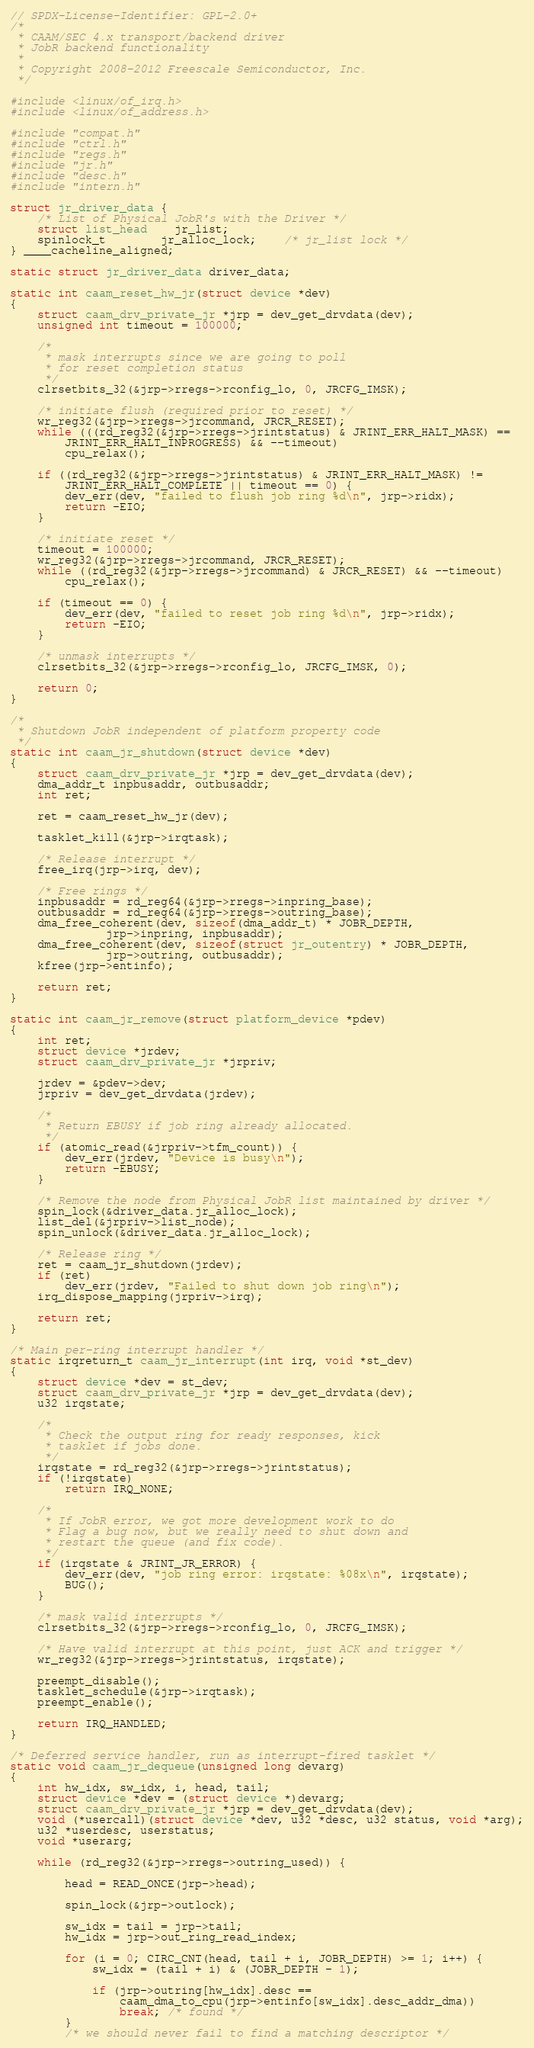<code> <loc_0><loc_0><loc_500><loc_500><_C_>// SPDX-License-Identifier: GPL-2.0+
/*
 * CAAM/SEC 4.x transport/backend driver
 * JobR backend functionality
 *
 * Copyright 2008-2012 Freescale Semiconductor, Inc.
 */

#include <linux/of_irq.h>
#include <linux/of_address.h>

#include "compat.h"
#include "ctrl.h"
#include "regs.h"
#include "jr.h"
#include "desc.h"
#include "intern.h"

struct jr_driver_data {
	/* List of Physical JobR's with the Driver */
	struct list_head	jr_list;
	spinlock_t		jr_alloc_lock;	/* jr_list lock */
} ____cacheline_aligned;

static struct jr_driver_data driver_data;

static int caam_reset_hw_jr(struct device *dev)
{
	struct caam_drv_private_jr *jrp = dev_get_drvdata(dev);
	unsigned int timeout = 100000;

	/*
	 * mask interrupts since we are going to poll
	 * for reset completion status
	 */
	clrsetbits_32(&jrp->rregs->rconfig_lo, 0, JRCFG_IMSK);

	/* initiate flush (required prior to reset) */
	wr_reg32(&jrp->rregs->jrcommand, JRCR_RESET);
	while (((rd_reg32(&jrp->rregs->jrintstatus) & JRINT_ERR_HALT_MASK) ==
		JRINT_ERR_HALT_INPROGRESS) && --timeout)
		cpu_relax();

	if ((rd_reg32(&jrp->rregs->jrintstatus) & JRINT_ERR_HALT_MASK) !=
	    JRINT_ERR_HALT_COMPLETE || timeout == 0) {
		dev_err(dev, "failed to flush job ring %d\n", jrp->ridx);
		return -EIO;
	}

	/* initiate reset */
	timeout = 100000;
	wr_reg32(&jrp->rregs->jrcommand, JRCR_RESET);
	while ((rd_reg32(&jrp->rregs->jrcommand) & JRCR_RESET) && --timeout)
		cpu_relax();

	if (timeout == 0) {
		dev_err(dev, "failed to reset job ring %d\n", jrp->ridx);
		return -EIO;
	}

	/* unmask interrupts */
	clrsetbits_32(&jrp->rregs->rconfig_lo, JRCFG_IMSK, 0);

	return 0;
}

/*
 * Shutdown JobR independent of platform property code
 */
static int caam_jr_shutdown(struct device *dev)
{
	struct caam_drv_private_jr *jrp = dev_get_drvdata(dev);
	dma_addr_t inpbusaddr, outbusaddr;
	int ret;

	ret = caam_reset_hw_jr(dev);

	tasklet_kill(&jrp->irqtask);

	/* Release interrupt */
	free_irq(jrp->irq, dev);

	/* Free rings */
	inpbusaddr = rd_reg64(&jrp->rregs->inpring_base);
	outbusaddr = rd_reg64(&jrp->rregs->outring_base);
	dma_free_coherent(dev, sizeof(dma_addr_t) * JOBR_DEPTH,
			  jrp->inpring, inpbusaddr);
	dma_free_coherent(dev, sizeof(struct jr_outentry) * JOBR_DEPTH,
			  jrp->outring, outbusaddr);
	kfree(jrp->entinfo);

	return ret;
}

static int caam_jr_remove(struct platform_device *pdev)
{
	int ret;
	struct device *jrdev;
	struct caam_drv_private_jr *jrpriv;

	jrdev = &pdev->dev;
	jrpriv = dev_get_drvdata(jrdev);

	/*
	 * Return EBUSY if job ring already allocated.
	 */
	if (atomic_read(&jrpriv->tfm_count)) {
		dev_err(jrdev, "Device is busy\n");
		return -EBUSY;
	}

	/* Remove the node from Physical JobR list maintained by driver */
	spin_lock(&driver_data.jr_alloc_lock);
	list_del(&jrpriv->list_node);
	spin_unlock(&driver_data.jr_alloc_lock);

	/* Release ring */
	ret = caam_jr_shutdown(jrdev);
	if (ret)
		dev_err(jrdev, "Failed to shut down job ring\n");
	irq_dispose_mapping(jrpriv->irq);

	return ret;
}

/* Main per-ring interrupt handler */
static irqreturn_t caam_jr_interrupt(int irq, void *st_dev)
{
	struct device *dev = st_dev;
	struct caam_drv_private_jr *jrp = dev_get_drvdata(dev);
	u32 irqstate;

	/*
	 * Check the output ring for ready responses, kick
	 * tasklet if jobs done.
	 */
	irqstate = rd_reg32(&jrp->rregs->jrintstatus);
	if (!irqstate)
		return IRQ_NONE;

	/*
	 * If JobR error, we got more development work to do
	 * Flag a bug now, but we really need to shut down and
	 * restart the queue (and fix code).
	 */
	if (irqstate & JRINT_JR_ERROR) {
		dev_err(dev, "job ring error: irqstate: %08x\n", irqstate);
		BUG();
	}

	/* mask valid interrupts */
	clrsetbits_32(&jrp->rregs->rconfig_lo, 0, JRCFG_IMSK);

	/* Have valid interrupt at this point, just ACK and trigger */
	wr_reg32(&jrp->rregs->jrintstatus, irqstate);

	preempt_disable();
	tasklet_schedule(&jrp->irqtask);
	preempt_enable();

	return IRQ_HANDLED;
}

/* Deferred service handler, run as interrupt-fired tasklet */
static void caam_jr_dequeue(unsigned long devarg)
{
	int hw_idx, sw_idx, i, head, tail;
	struct device *dev = (struct device *)devarg;
	struct caam_drv_private_jr *jrp = dev_get_drvdata(dev);
	void (*usercall)(struct device *dev, u32 *desc, u32 status, void *arg);
	u32 *userdesc, userstatus;
	void *userarg;

	while (rd_reg32(&jrp->rregs->outring_used)) {

		head = READ_ONCE(jrp->head);

		spin_lock(&jrp->outlock);

		sw_idx = tail = jrp->tail;
		hw_idx = jrp->out_ring_read_index;

		for (i = 0; CIRC_CNT(head, tail + i, JOBR_DEPTH) >= 1; i++) {
			sw_idx = (tail + i) & (JOBR_DEPTH - 1);

			if (jrp->outring[hw_idx].desc ==
			    caam_dma_to_cpu(jrp->entinfo[sw_idx].desc_addr_dma))
				break; /* found */
		}
		/* we should never fail to find a matching descriptor */</code> 